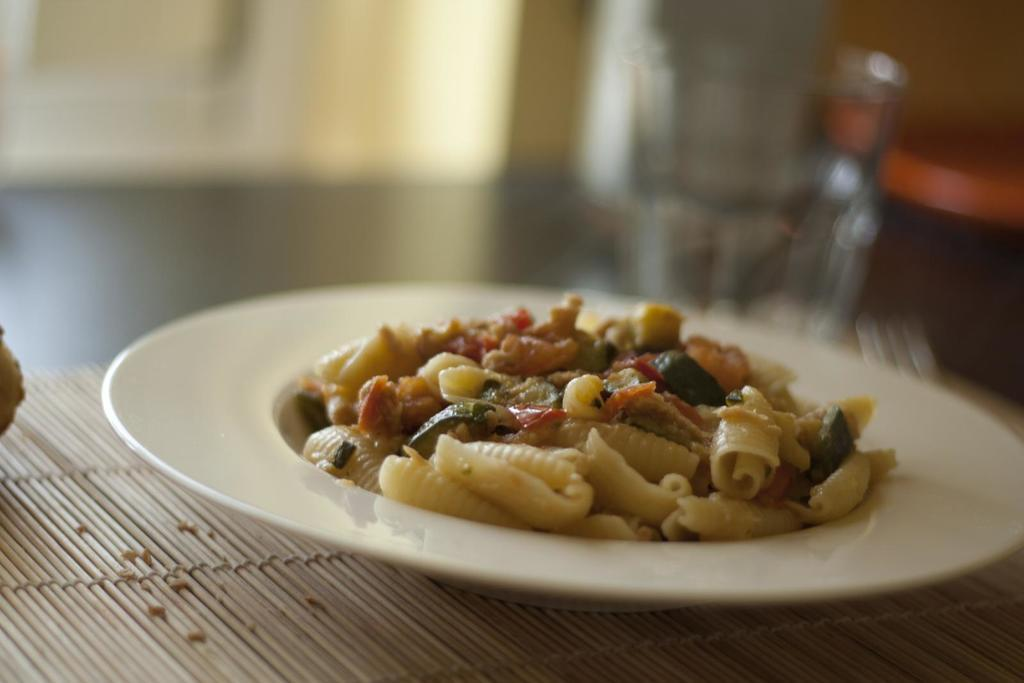What is the main subject in the foreground of the image? There is a food item on a plate in the foreground of the image. What is located at the bottom of the image? There is a mat at the bottom of the image. How would you describe the background of the image? The background of the image is blurred. What type of yarn is being used to create the low-hanging sheet in the image? There is no yarn or sheet present in the image; it features a food item on a plate and a mat at the bottom. 